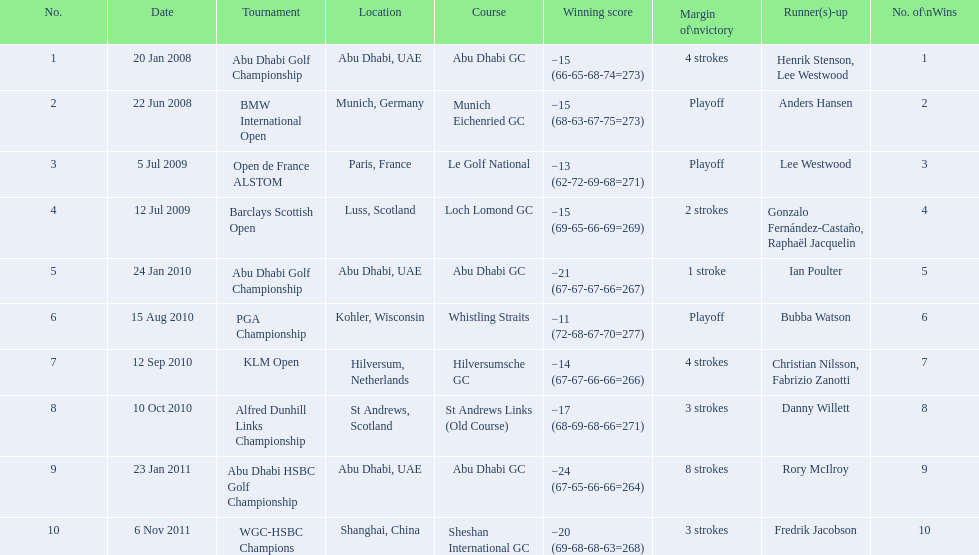How many strokes were in the klm open by martin kaymer? 4 strokes. How many strokes were in the abu dhabi golf championship? 4 strokes. How many more strokes were there in the klm than the barclays open? 2 strokes. 